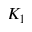<formula> <loc_0><loc_0><loc_500><loc_500>K _ { 1 }</formula> 